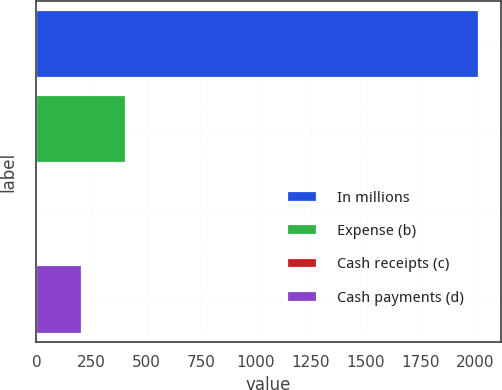Convert chart to OTSL. <chart><loc_0><loc_0><loc_500><loc_500><bar_chart><fcel>In millions<fcel>Expense (b)<fcel>Cash receipts (c)<fcel>Cash payments (d)<nl><fcel>2015<fcel>408.6<fcel>7<fcel>207.8<nl></chart> 